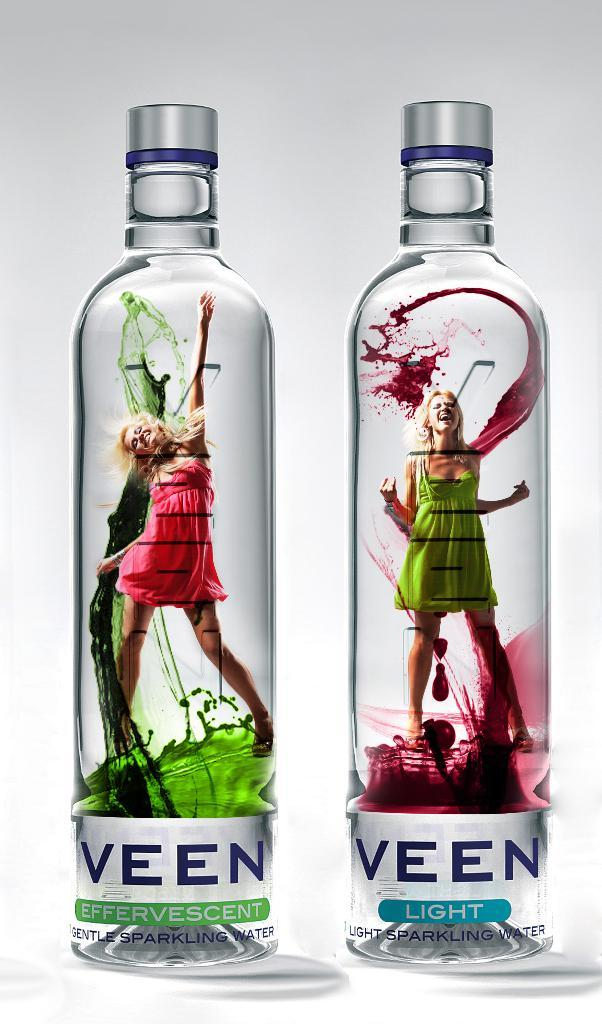How many bottles are visible in the image? There are two bottles in the image. What is depicted on the bottles? The bottles have photos of women on them. Are there any ants crawling on the bottles in the image? There is no mention of ants in the provided facts, so we cannot determine if there are any ants on the bottles in the image. 